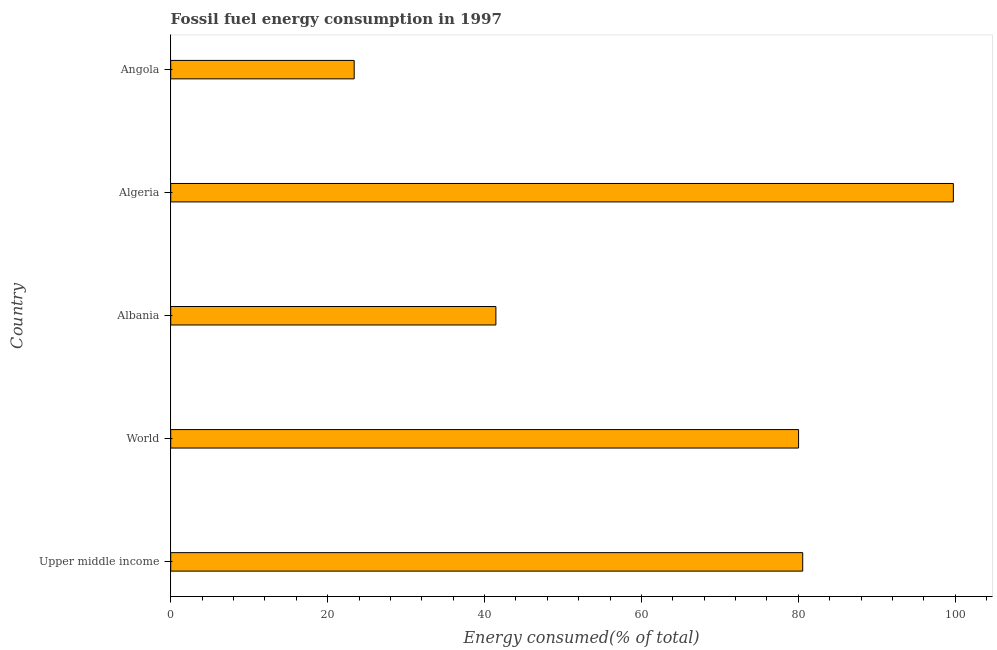Does the graph contain any zero values?
Your response must be concise. No. Does the graph contain grids?
Ensure brevity in your answer.  No. What is the title of the graph?
Provide a succinct answer. Fossil fuel energy consumption in 1997. What is the label or title of the X-axis?
Your response must be concise. Energy consumed(% of total). What is the fossil fuel energy consumption in Albania?
Provide a short and direct response. 41.45. Across all countries, what is the maximum fossil fuel energy consumption?
Your answer should be compact. 99.76. Across all countries, what is the minimum fossil fuel energy consumption?
Ensure brevity in your answer.  23.39. In which country was the fossil fuel energy consumption maximum?
Offer a very short reply. Algeria. In which country was the fossil fuel energy consumption minimum?
Give a very brief answer. Angola. What is the sum of the fossil fuel energy consumption?
Keep it short and to the point. 325.19. What is the difference between the fossil fuel energy consumption in Upper middle income and World?
Give a very brief answer. 0.53. What is the average fossil fuel energy consumption per country?
Offer a very short reply. 65.04. What is the median fossil fuel energy consumption?
Provide a short and direct response. 80.03. In how many countries, is the fossil fuel energy consumption greater than 80 %?
Offer a terse response. 3. What is the ratio of the fossil fuel energy consumption in Albania to that in World?
Ensure brevity in your answer.  0.52. Is the fossil fuel energy consumption in Albania less than that in World?
Offer a terse response. Yes. Is the difference between the fossil fuel energy consumption in Albania and Algeria greater than the difference between any two countries?
Give a very brief answer. No. What is the difference between the highest and the second highest fossil fuel energy consumption?
Your answer should be very brief. 19.2. Is the sum of the fossil fuel energy consumption in Albania and Algeria greater than the maximum fossil fuel energy consumption across all countries?
Ensure brevity in your answer.  Yes. What is the difference between the highest and the lowest fossil fuel energy consumption?
Make the answer very short. 76.38. Are all the bars in the graph horizontal?
Your response must be concise. Yes. How many countries are there in the graph?
Give a very brief answer. 5. Are the values on the major ticks of X-axis written in scientific E-notation?
Make the answer very short. No. What is the Energy consumed(% of total) of Upper middle income?
Offer a terse response. 80.56. What is the Energy consumed(% of total) in World?
Give a very brief answer. 80.03. What is the Energy consumed(% of total) of Albania?
Offer a very short reply. 41.45. What is the Energy consumed(% of total) of Algeria?
Give a very brief answer. 99.76. What is the Energy consumed(% of total) of Angola?
Make the answer very short. 23.39. What is the difference between the Energy consumed(% of total) in Upper middle income and World?
Make the answer very short. 0.53. What is the difference between the Energy consumed(% of total) in Upper middle income and Albania?
Keep it short and to the point. 39.11. What is the difference between the Energy consumed(% of total) in Upper middle income and Algeria?
Your answer should be compact. -19.2. What is the difference between the Energy consumed(% of total) in Upper middle income and Angola?
Give a very brief answer. 57.17. What is the difference between the Energy consumed(% of total) in World and Albania?
Offer a terse response. 38.58. What is the difference between the Energy consumed(% of total) in World and Algeria?
Your answer should be very brief. -19.73. What is the difference between the Energy consumed(% of total) in World and Angola?
Your answer should be very brief. 56.65. What is the difference between the Energy consumed(% of total) in Albania and Algeria?
Your response must be concise. -58.31. What is the difference between the Energy consumed(% of total) in Albania and Angola?
Provide a short and direct response. 18.06. What is the difference between the Energy consumed(% of total) in Algeria and Angola?
Your answer should be very brief. 76.38. What is the ratio of the Energy consumed(% of total) in Upper middle income to that in World?
Your response must be concise. 1.01. What is the ratio of the Energy consumed(% of total) in Upper middle income to that in Albania?
Your answer should be compact. 1.94. What is the ratio of the Energy consumed(% of total) in Upper middle income to that in Algeria?
Offer a terse response. 0.81. What is the ratio of the Energy consumed(% of total) in Upper middle income to that in Angola?
Your answer should be compact. 3.44. What is the ratio of the Energy consumed(% of total) in World to that in Albania?
Keep it short and to the point. 1.93. What is the ratio of the Energy consumed(% of total) in World to that in Algeria?
Provide a succinct answer. 0.8. What is the ratio of the Energy consumed(% of total) in World to that in Angola?
Give a very brief answer. 3.42. What is the ratio of the Energy consumed(% of total) in Albania to that in Algeria?
Provide a short and direct response. 0.41. What is the ratio of the Energy consumed(% of total) in Albania to that in Angola?
Your answer should be very brief. 1.77. What is the ratio of the Energy consumed(% of total) in Algeria to that in Angola?
Offer a terse response. 4.27. 